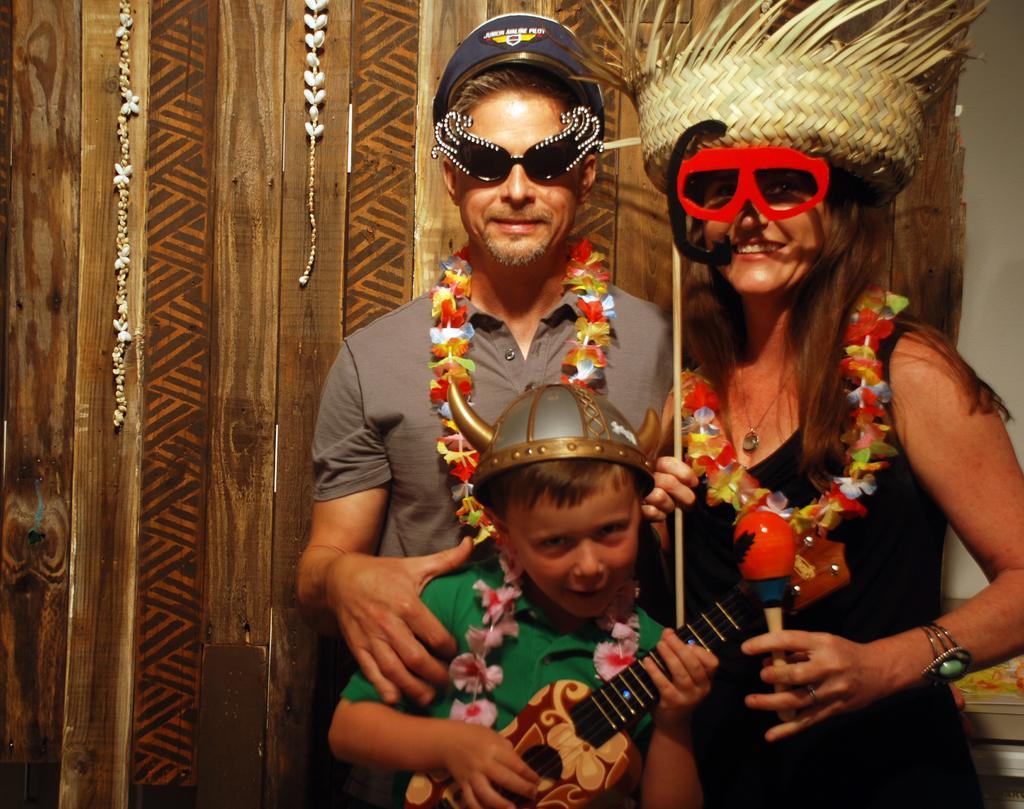Please provide a concise description of this image. In this picture there are three people wearing different costumes. 